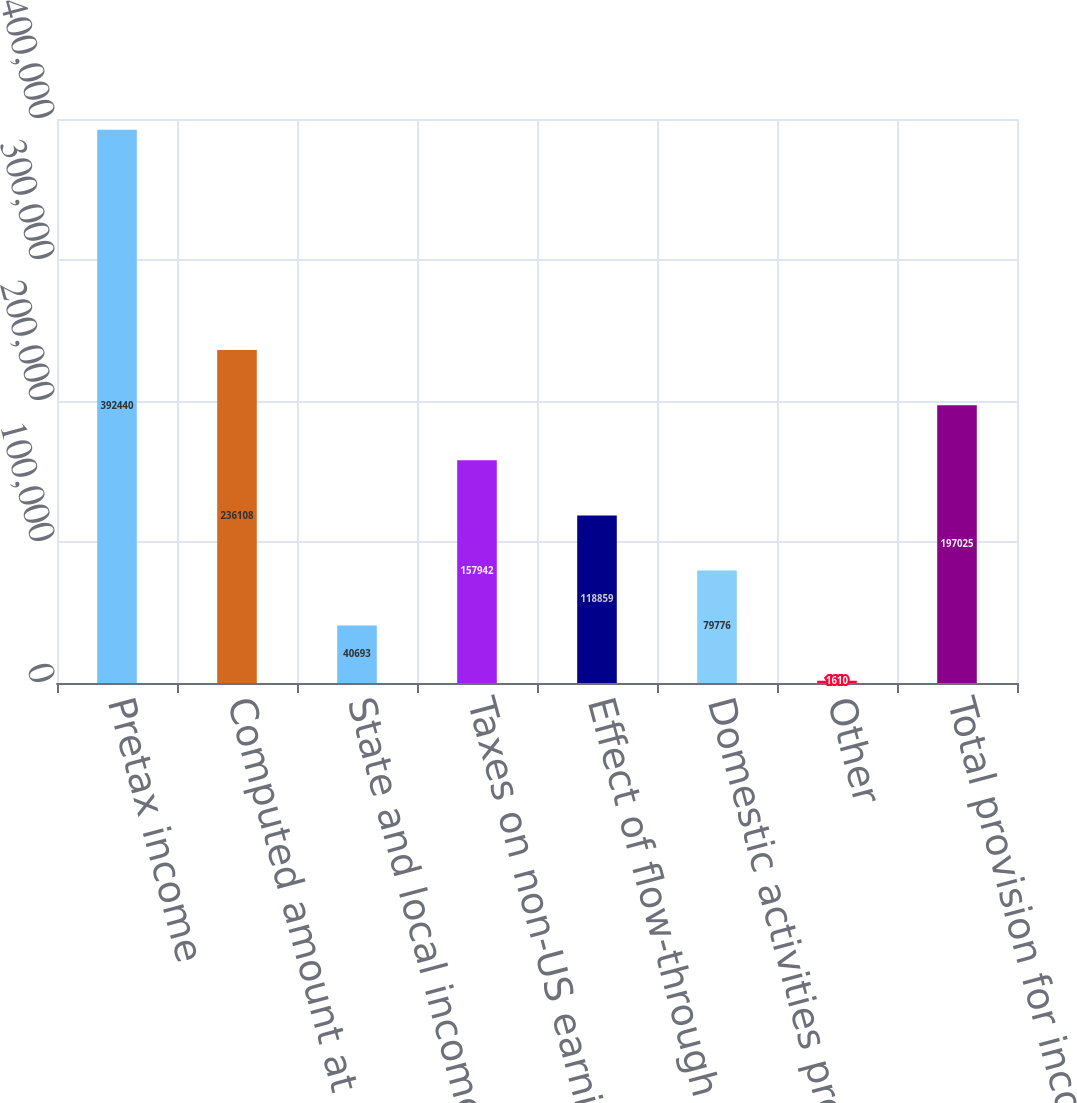Convert chart to OTSL. <chart><loc_0><loc_0><loc_500><loc_500><bar_chart><fcel>Pretax income<fcel>Computed amount at statutory<fcel>State and local income tax<fcel>Taxes on non-US earnings-net<fcel>Effect of flow-through<fcel>Domestic activities production<fcel>Other<fcel>Total provision for income<nl><fcel>392440<fcel>236108<fcel>40693<fcel>157942<fcel>118859<fcel>79776<fcel>1610<fcel>197025<nl></chart> 